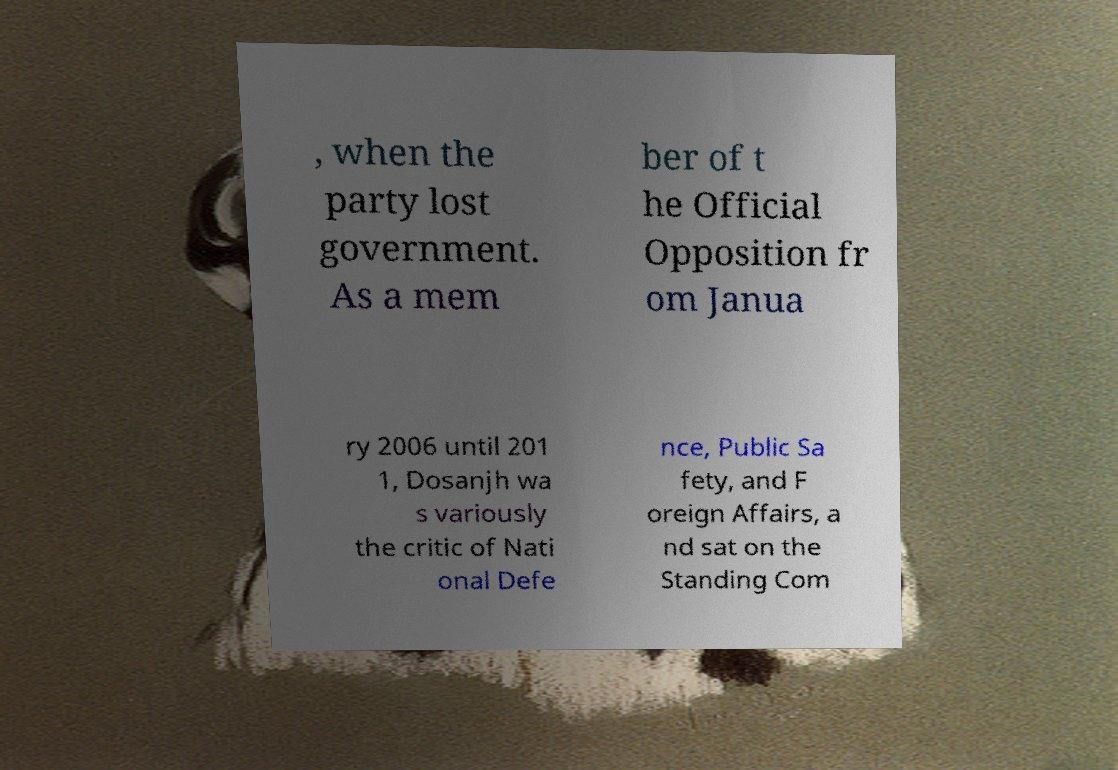Please identify and transcribe the text found in this image. , when the party lost government. As a mem ber of t he Official Opposition fr om Janua ry 2006 until 201 1, Dosanjh wa s variously the critic of Nati onal Defe nce, Public Sa fety, and F oreign Affairs, a nd sat on the Standing Com 